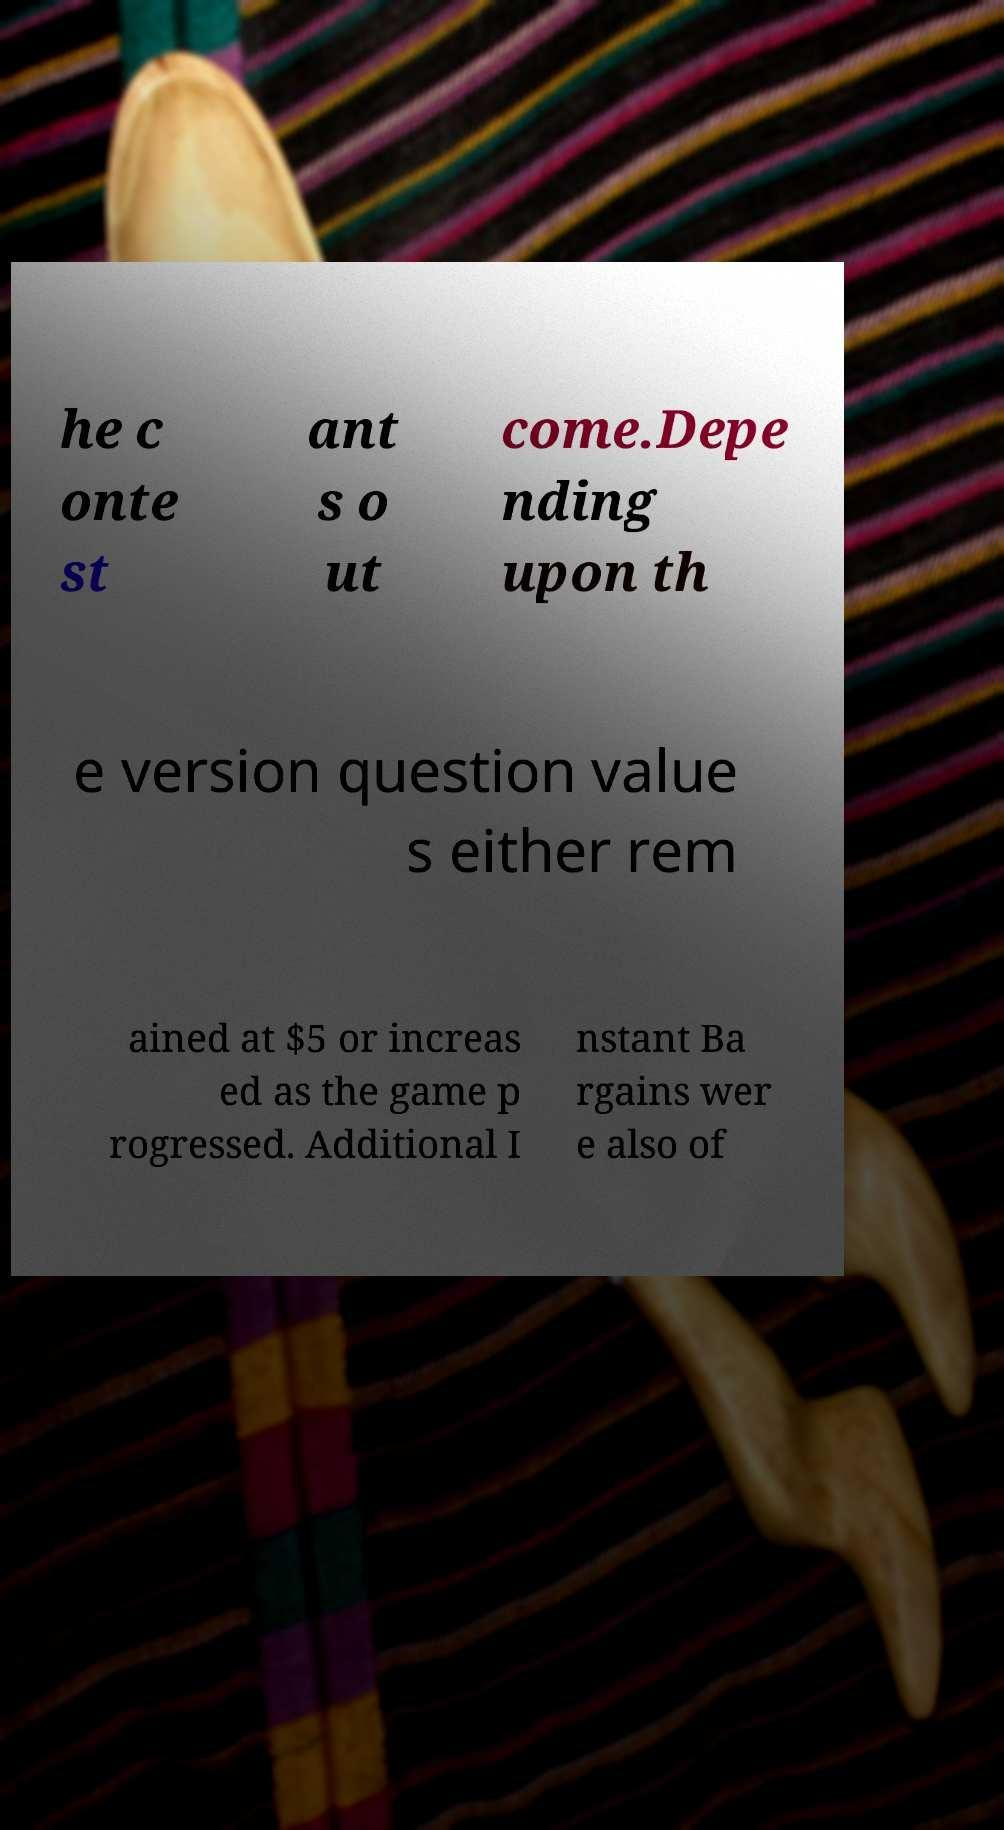There's text embedded in this image that I need extracted. Can you transcribe it verbatim? he c onte st ant s o ut come.Depe nding upon th e version question value s either rem ained at $5 or increas ed as the game p rogressed. Additional I nstant Ba rgains wer e also of 